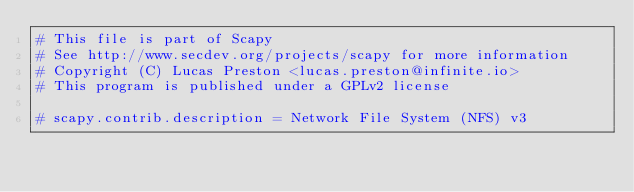Convert code to text. <code><loc_0><loc_0><loc_500><loc_500><_Python_># This file is part of Scapy
# See http://www.secdev.org/projects/scapy for more information
# Copyright (C) Lucas Preston <lucas.preston@infinite.io>
# This program is published under a GPLv2 license

# scapy.contrib.description = Network File System (NFS) v3</code> 